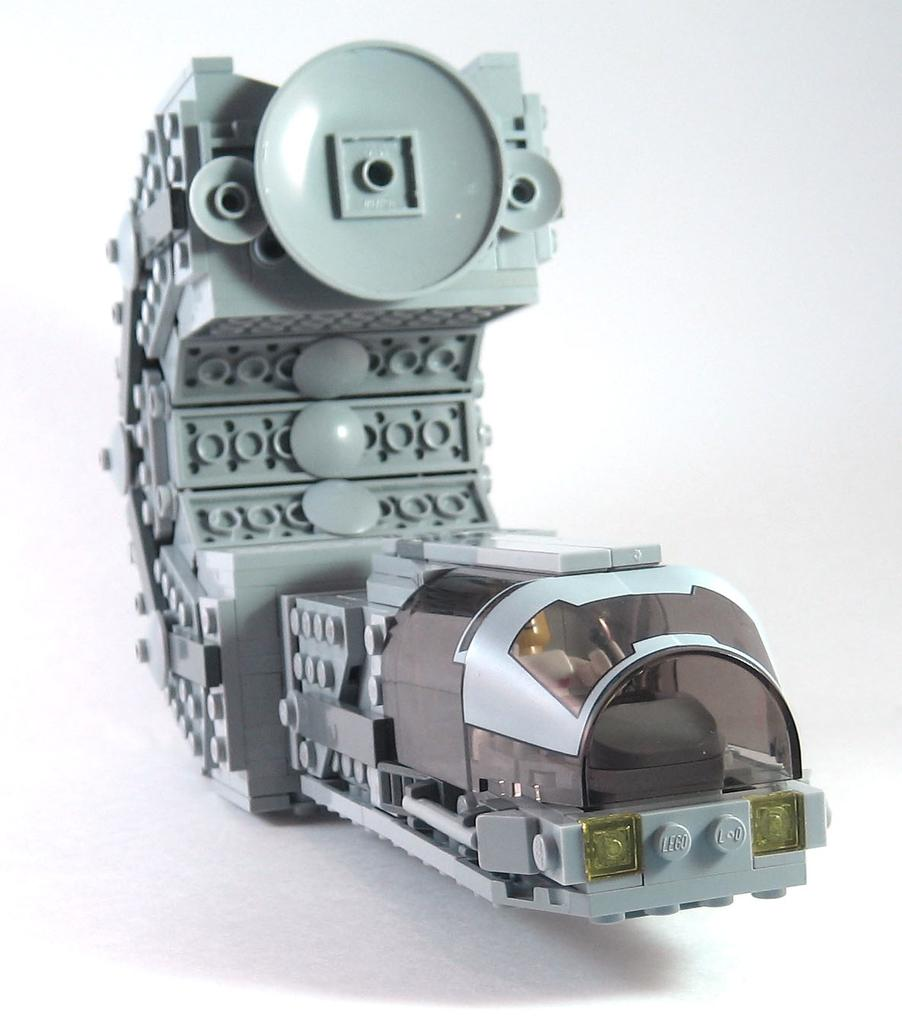What object can be seen in the image? There is a toy in the image. What color is the background of the image? The background of the image is white. Is there any honey dripping from the toy in the image? There is no honey present in the image, and therefore no honey dripping from the toy. 